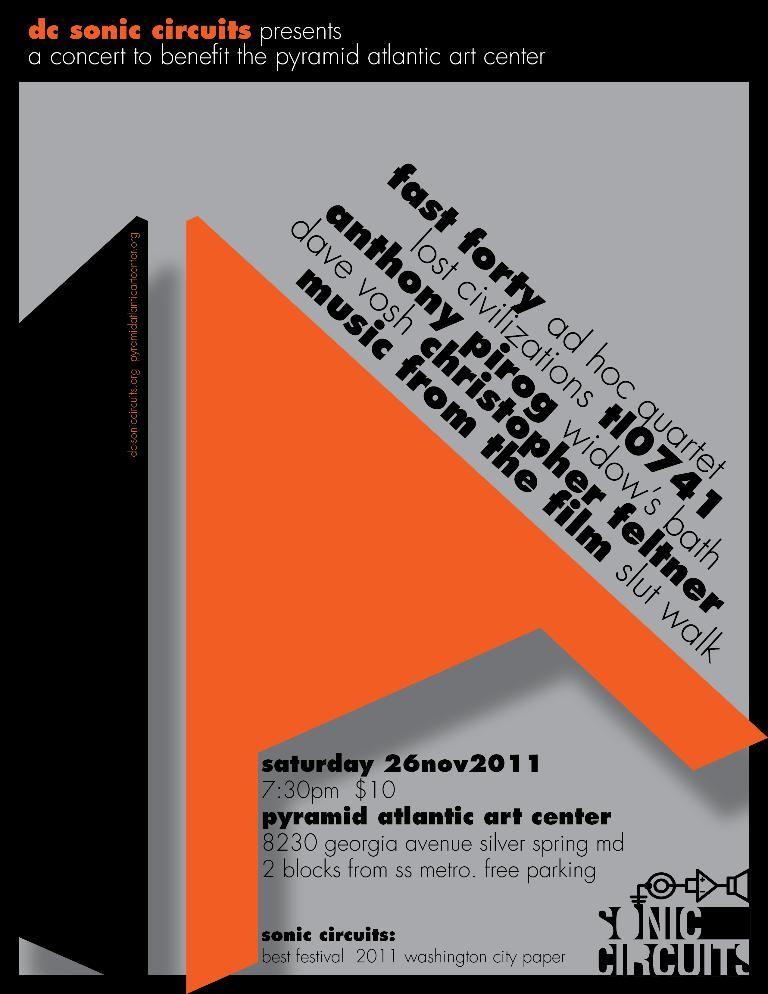<image>
Give a short and clear explanation of the subsequent image. Poster promoting concert at the pyramid atlantic art center on November 26th 2011. 